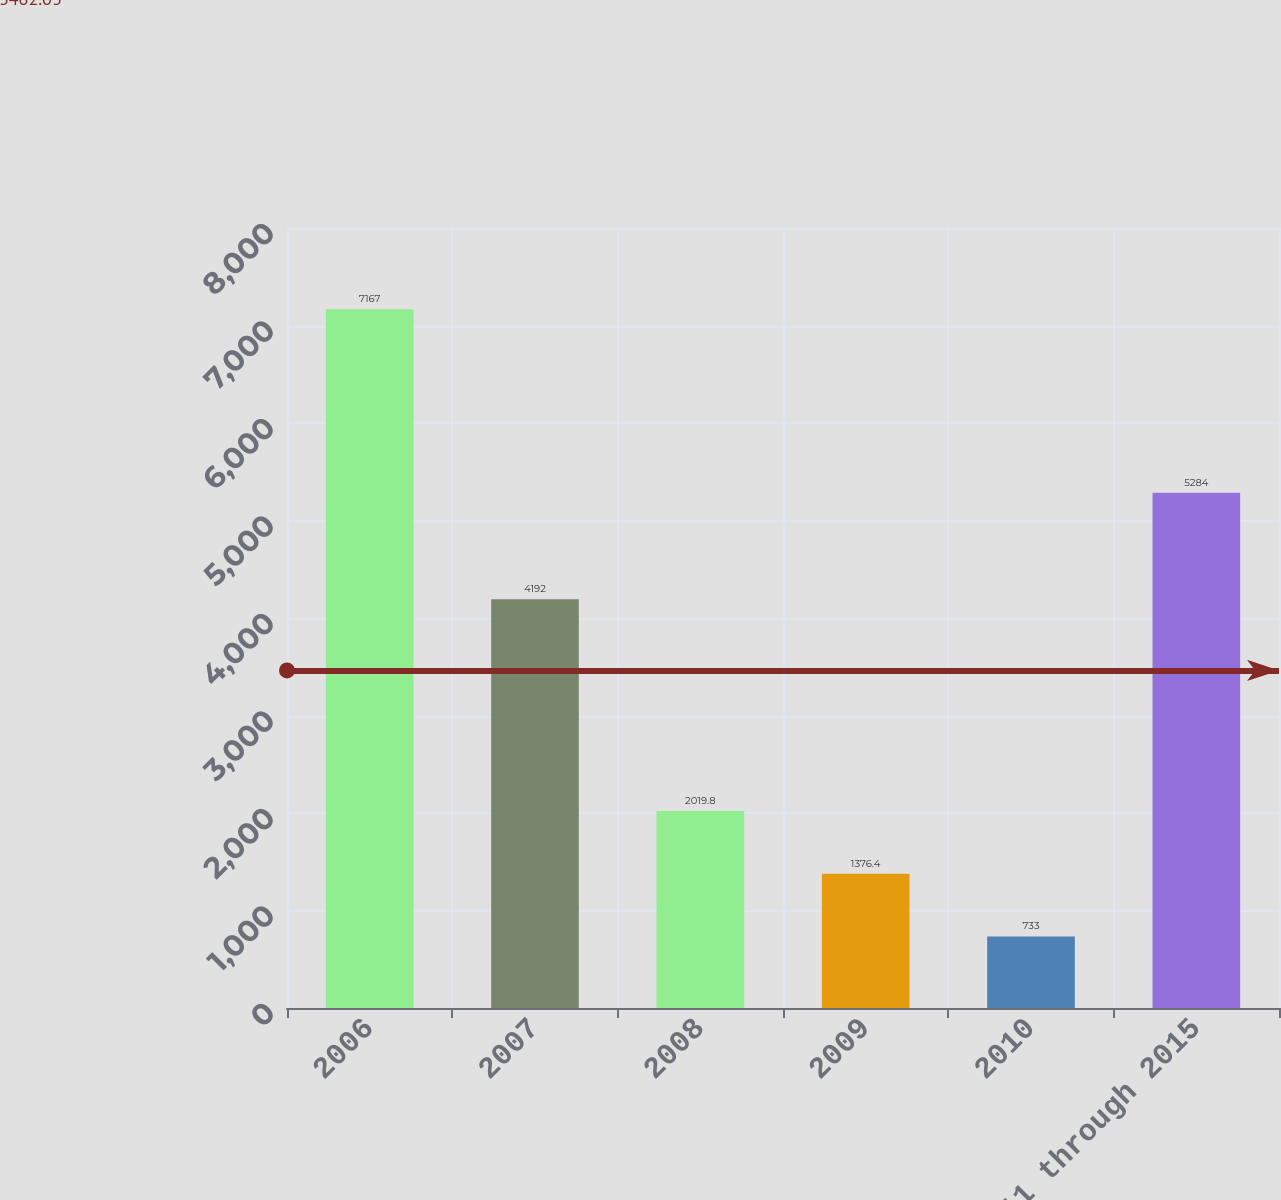Convert chart to OTSL. <chart><loc_0><loc_0><loc_500><loc_500><bar_chart><fcel>2006<fcel>2007<fcel>2008<fcel>2009<fcel>2010<fcel>2011 through 2015<nl><fcel>7167<fcel>4192<fcel>2019.8<fcel>1376.4<fcel>733<fcel>5284<nl></chart> 